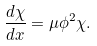<formula> <loc_0><loc_0><loc_500><loc_500>\frac { d \chi } { d x } = \mu \phi ^ { 2 } \chi .</formula> 